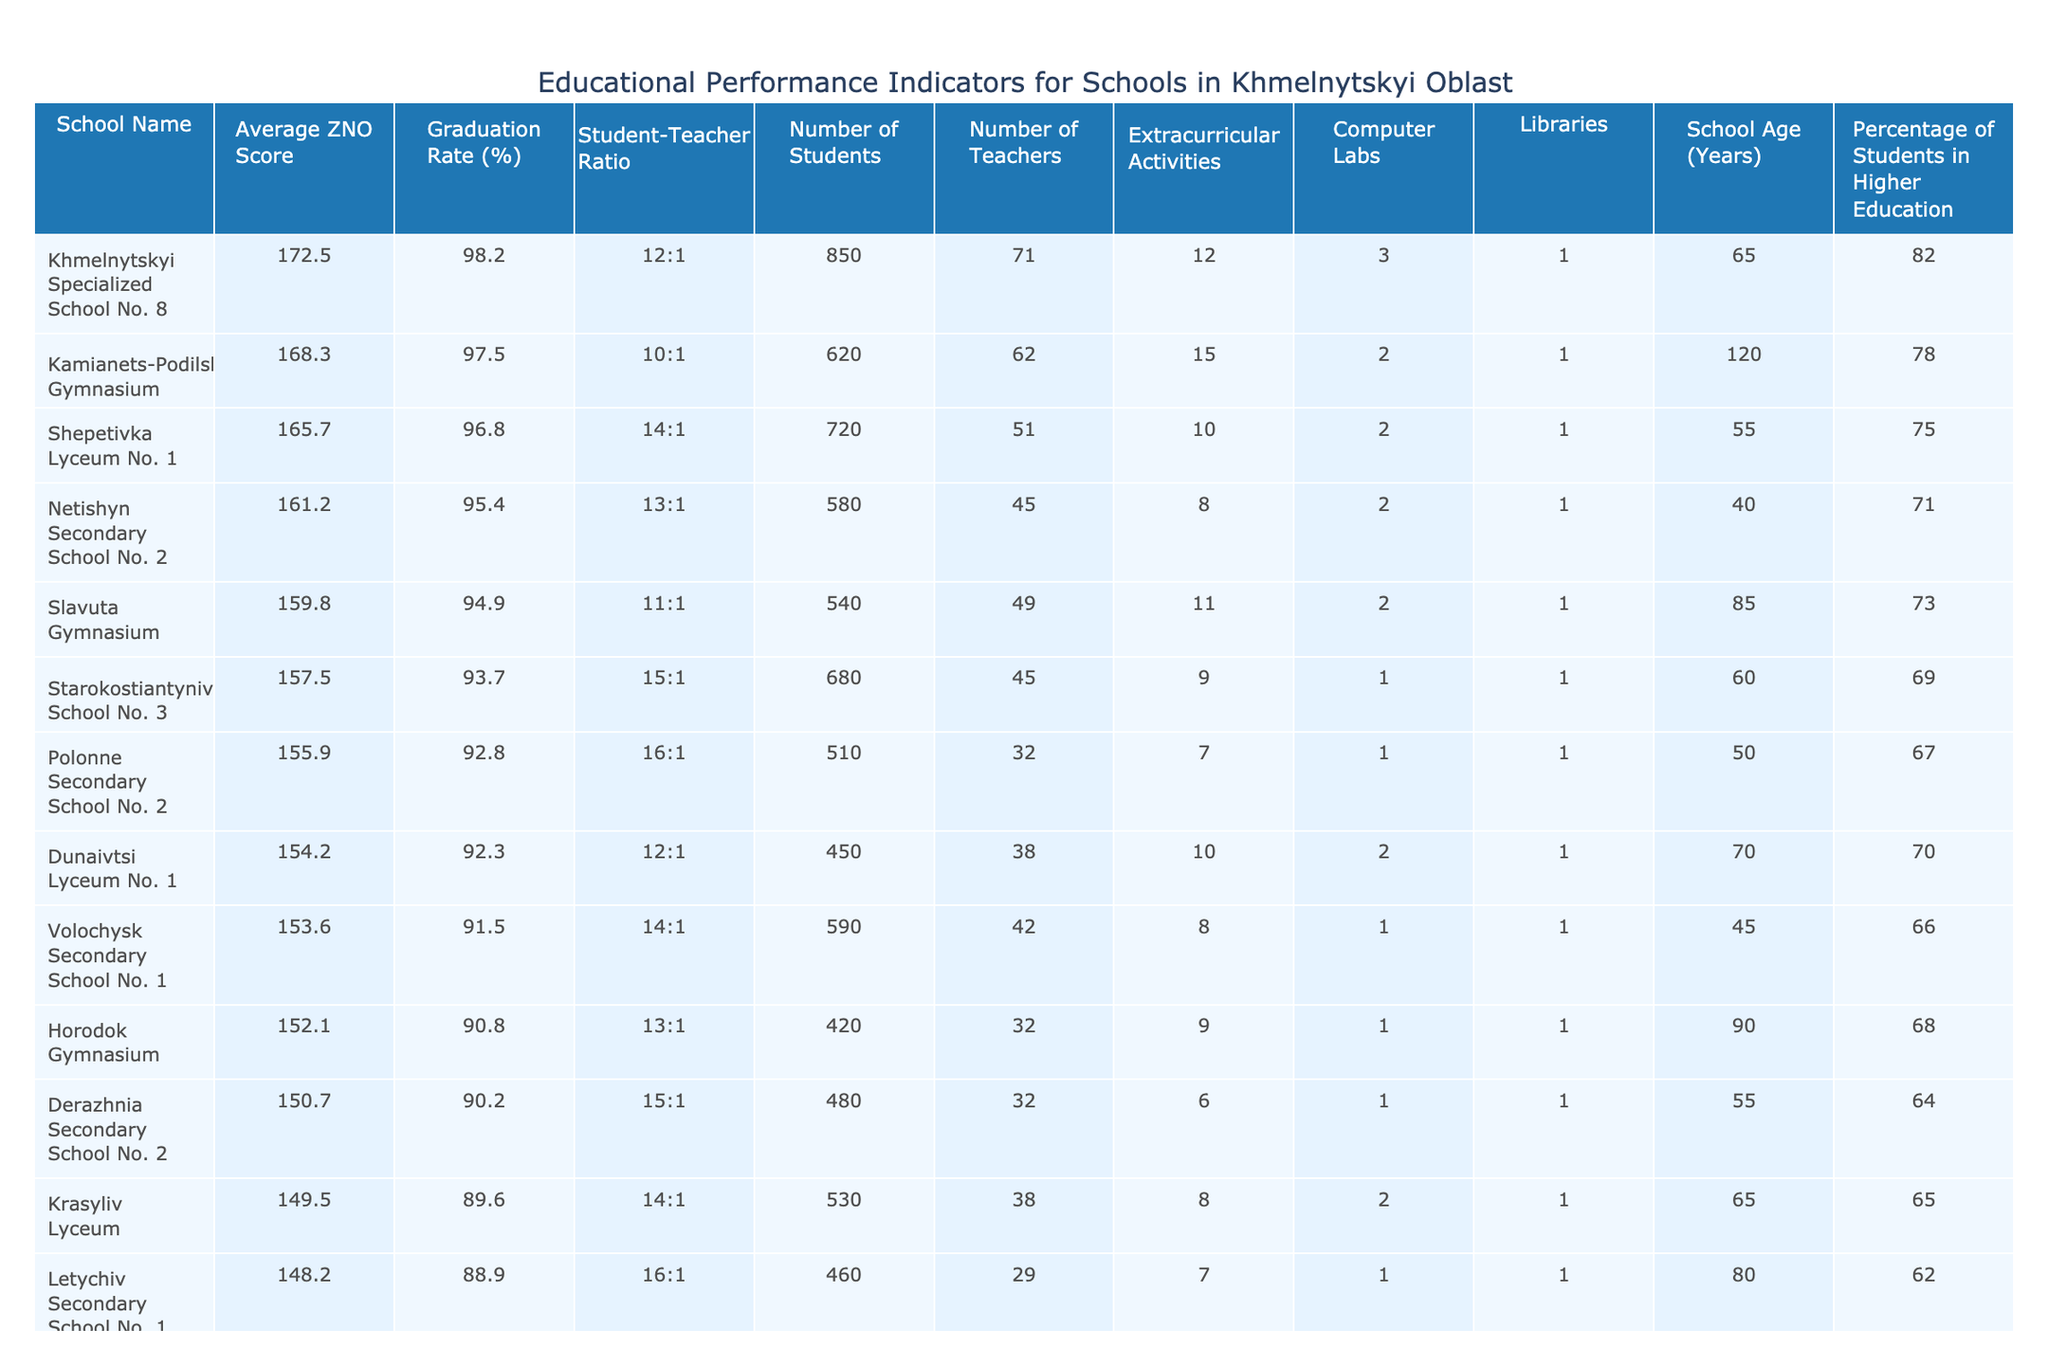What is the average ZNO score of schools in Khmelnytskyi Oblast? First, we add the ZNO scores of all the schools: 172.5 + 168.3 + 165.7 + 161.2 + 159.8 + 157.5 + 155.9 + 154.2 + 153.6 + 152.1 + 150.7 + 149.5 + 148.2 + 146.8 + 145.3 = 2373.5. There are 15 schools, so we divide the total by 15 to find the average: 2373.5 / 15 = 158.23.
Answer: 158.23 Which school has the highest graduation rate? By reviewing the graduation rates for each school, Khmelnytskyi Specialized School No. 8 has the highest rate at 98.2%.
Answer: Khmelnytskyi Specialized School No. 8 What is the student-teacher ratio for Kamianets-Podilskyi Gymnasium? The student-teacher ratio is listed directly in the table for Kamianets-Podilskyi Gymnasium as 10:1.
Answer: 10:1 How many schools have a percentage of students in higher education greater than 75%? By checking each school's percentage of students in higher education, the following schools meet the criteria: Khmelnytskyi Specialized School No. 8 (82%), Kamianets-Podilskyi Gymnasium (78%), Shepetivka Lyceum No. 1 (75%). This totals to 3 schools.
Answer: 3 Is the average graduation rate for schools in Shepetivka higher than 95%? The graduation rate for Shepetivka Lyceum No. 1 is 96.8%, which is higher than 95%. Thus, the statement is true.
Answer: Yes What is the total number of students across all schools listed in the table? We sum the number of students in each school: 850 + 620 + 720 + 580 + 540 + 680 + 510 + 450 + 590 + 420 + 480 + 530 + 460 + 380 + 420 = 8610.
Answer: 8610 Which school has the most extracurricular activities? Examining the table, Kamianets-Podilskyi Gymnasium has the most extracurricular activities listed at 15.
Answer: Kamianets-Podilskyi Gymnasium What is the average number of libraries in the listed schools? We find the total number of libraries: 1 + 1 + 1 + 1 + 1 + 1 + 1 + 1 + 1 + 1 + 1 + 1 + 1 + 1 + 1 = 15. Dividing by the number of schools (15) gives us an average of 15 / 15 = 1.
Answer: 1 Based on the data, which school has the lowest average ZNO score? Comparing the ZNO scores, Teofipol Secondary School has the lowest score of 145.3.
Answer: Teofipol Secondary School How does the student-teacher ratio of Slavuta Gymnasium compare to the average of all schools? The student-teacher ratio for Slavuta Gymnasium is 11:1. To find the average ratio, we convert each ratio to a numerical representation (e.g., 12:1 = 12, 10:1 = 10, etc.), sum them: (12 + 10 + 14 + 13 + 11 + 15 + 16 + 12 + 14 + 13 + 15 + 14 + 16 + 12 + 15) = 188. The average is 188 / 15 = 12.53. Since 11 < 12.53, Slavuta Gymnasium has a better ratio than average.
Answer: Better than average 